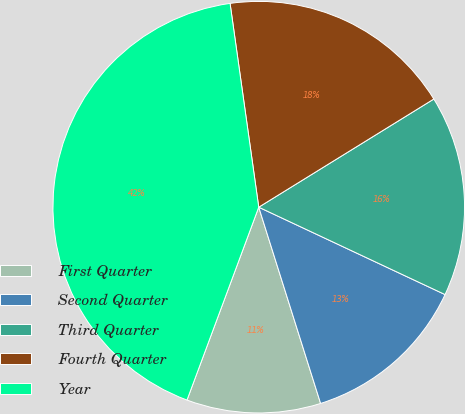Convert chart. <chart><loc_0><loc_0><loc_500><loc_500><pie_chart><fcel>First Quarter<fcel>Second Quarter<fcel>Third Quarter<fcel>Fourth Quarter<fcel>Year<nl><fcel>10.53%<fcel>13.16%<fcel>15.79%<fcel>18.42%<fcel>42.11%<nl></chart> 